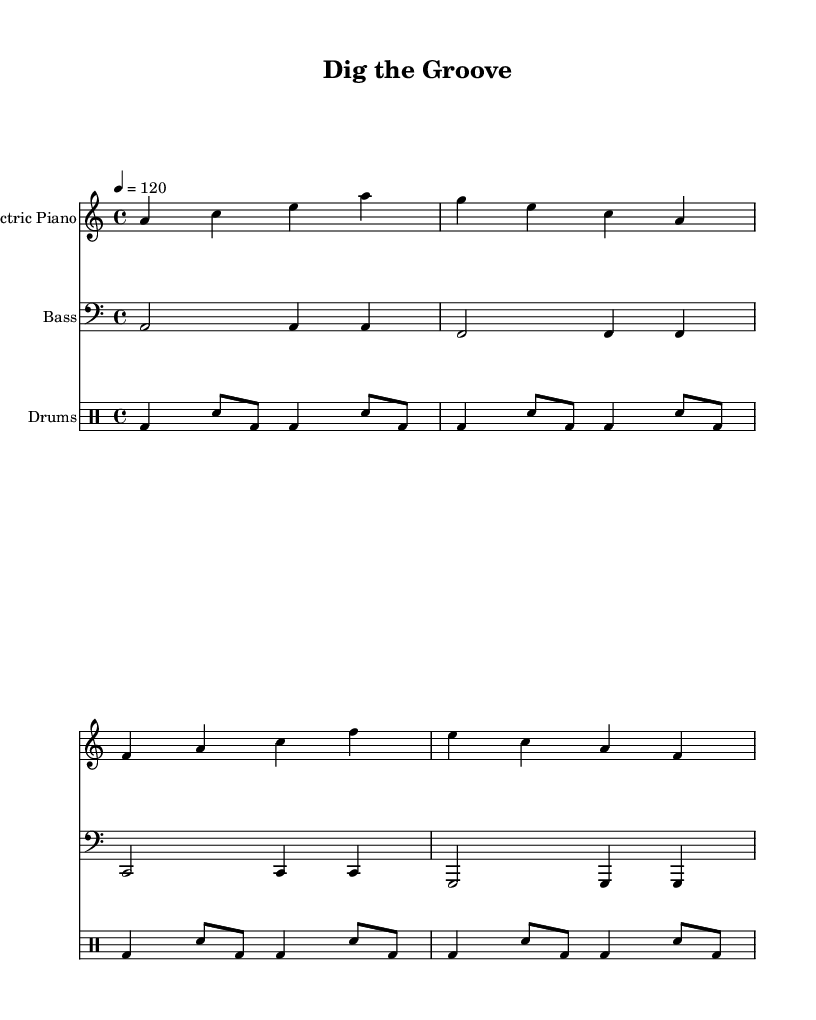What is the key signature of this music? The key signature is noted in the global section of the LilyPond code. It specifies A minor, which has no sharps or flats.
Answer: A minor What is the time signature of this music? The time signature is also found in the global section where it states 4/4, indicating four beats per measure.
Answer: 4/4 What is the tempo of this music? The tempo is indicated in the global section as 4 = 120, which means there are 120 beats per minute, or quarter notes.
Answer: 120 How many measures are in the electric piano part? The electric piano part has four measures, each separated by a bar line. This can be counted from the provided part in the sheet music.
Answer: Four Which instrument has the lowest pitch? The bass guitar is the instrument with the lowest pitch, as indicated by its notation on the bass clef in the music sheet.
Answer: Bass What rhythmic pattern is used by the drums? The drums follow a consistent pattern of bass drum and snare, with a sequence of quarter notes and eighth notes throughout the piece.
Answer: Bass and snare pattern How does the lyrics relate to the theme of archaeology? The lyrics reference "digging deep" and "ancient secrets," directly connecting to archaeological themes of exploration and discovery.
Answer: Ancient secrets 